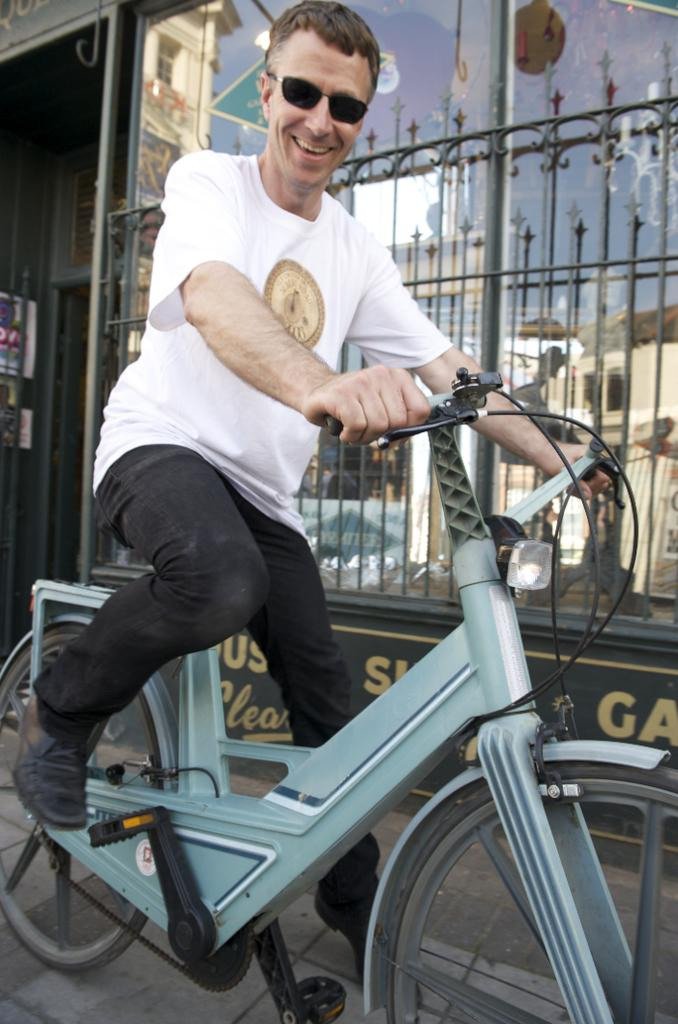Who is the main subject in the image? There is a person in the image. What is the person doing in the image? The person is riding a bicycle. What can be seen in the background of the image? There is a building in the background of the image. What type of hat is the person's mom wearing in the image? There is no mention of a mom or a hat in the image, so we cannot answer this question. 